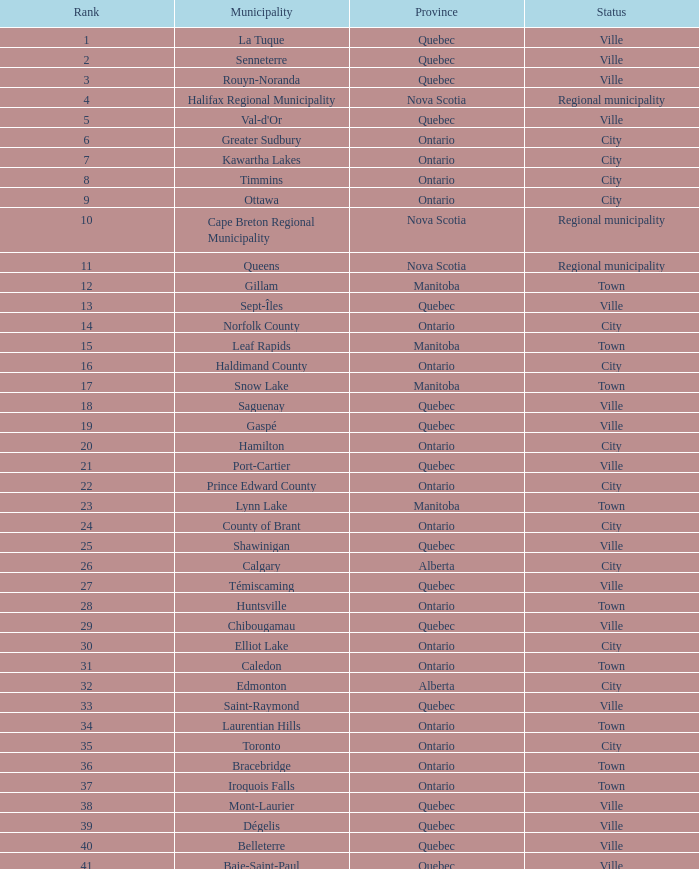For an area of 1050.14 km 2, what is the total rank? 22.0. 